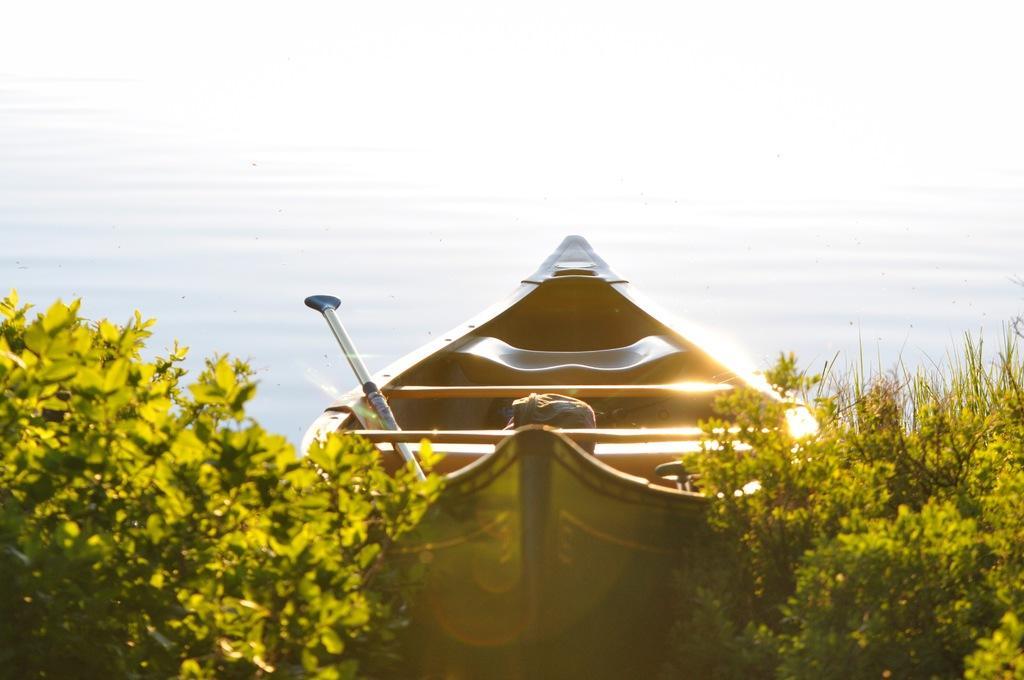What type of living organisms can be seen in the image? Plants can be seen in the image. What mode of transportation is present in the image? There is a boat in the image. What object is used for support or guidance in the image? There is a stick in the image. What item might be used for carrying or storing in the image? There is a bag in the image. What natural element is visible in the image? Water is visible in the image. What color is the shirt worn by the person in the image? There is no person present in the image, so there is no shirt to describe. What is the likelihood of a chance encounter happening in the image? The image does not depict any people or events, so it is impossible to determine the chance of a meeting occurring. 